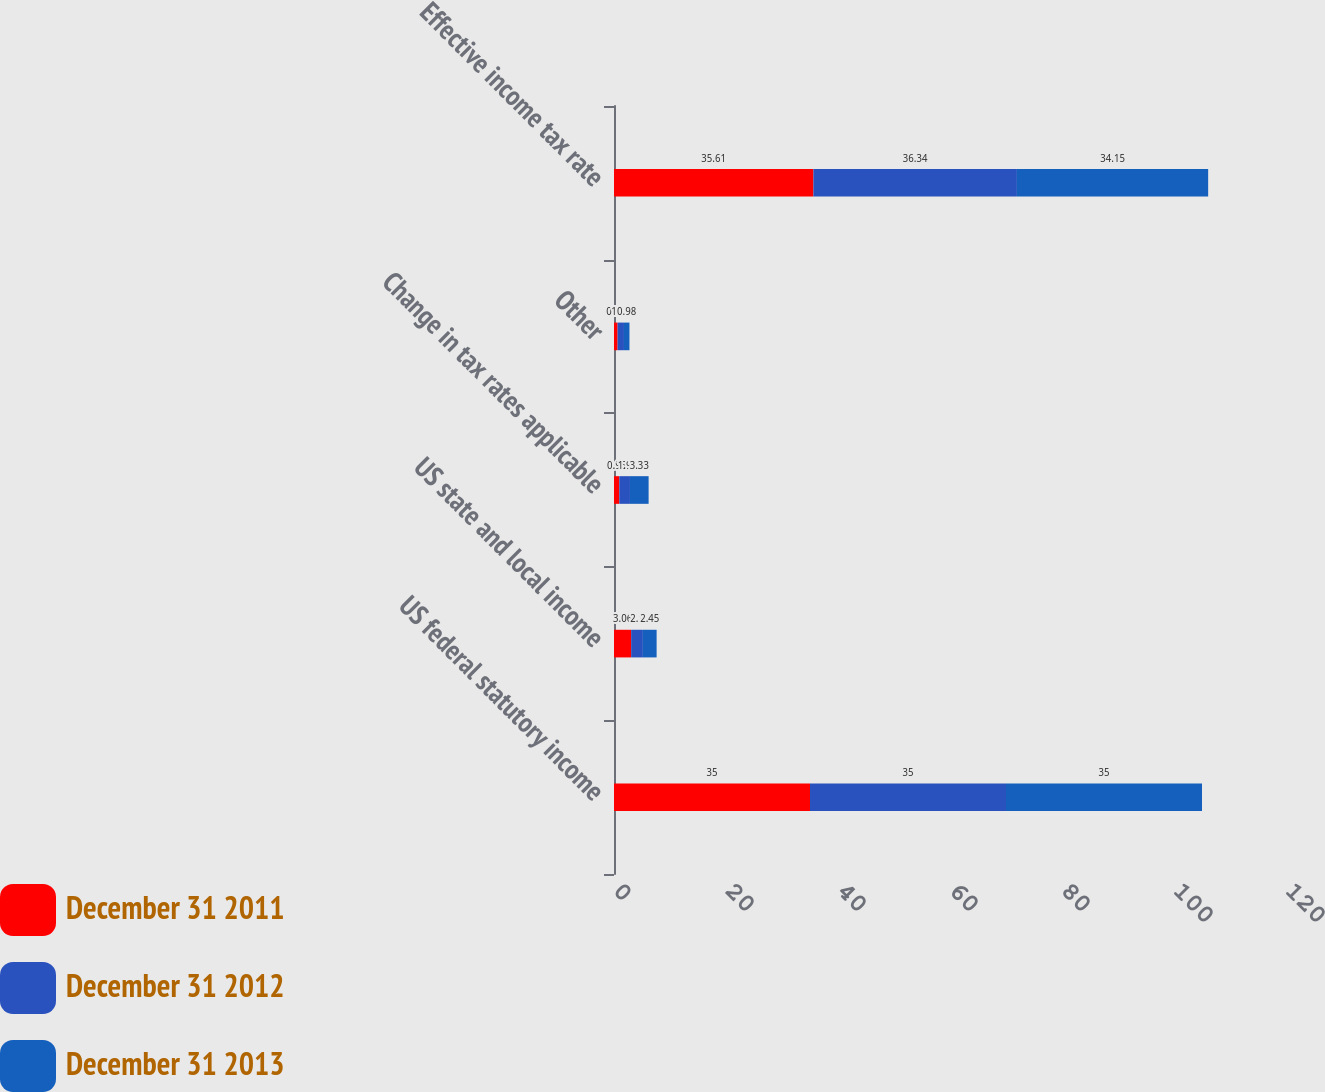<chart> <loc_0><loc_0><loc_500><loc_500><stacked_bar_chart><ecel><fcel>US federal statutory income<fcel>US state and local income<fcel>Change in tax rates applicable<fcel>Other<fcel>Effective income tax rate<nl><fcel>December 31 2011<fcel>35<fcel>3.06<fcel>0.95<fcel>0.64<fcel>35.61<nl><fcel>December 31 2012<fcel>35<fcel>2.1<fcel>1.9<fcel>1.14<fcel>36.34<nl><fcel>December 31 2013<fcel>35<fcel>2.45<fcel>3.33<fcel>0.98<fcel>34.15<nl></chart> 